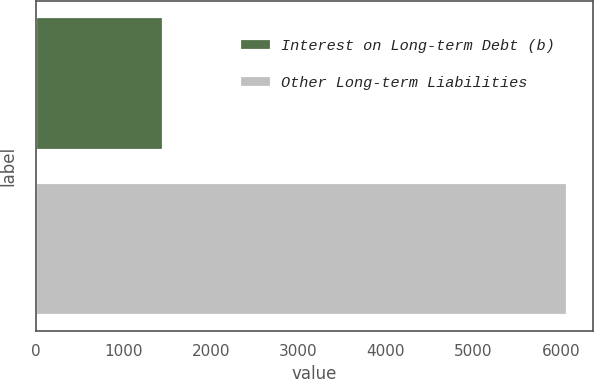Convert chart to OTSL. <chart><loc_0><loc_0><loc_500><loc_500><bar_chart><fcel>Interest on Long-term Debt (b)<fcel>Other Long-term Liabilities<nl><fcel>1454<fcel>6070<nl></chart> 